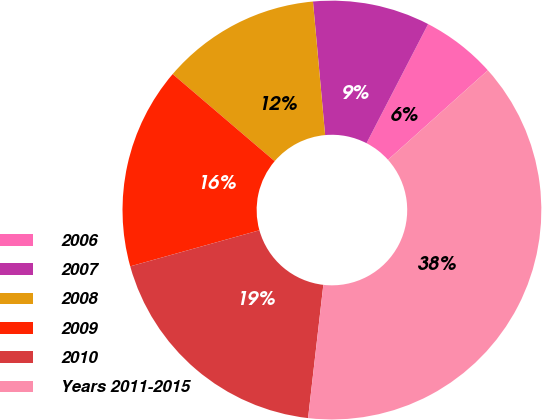Convert chart. <chart><loc_0><loc_0><loc_500><loc_500><pie_chart><fcel>2006<fcel>2007<fcel>2008<fcel>2009<fcel>2010<fcel>Years 2011-2015<nl><fcel>5.77%<fcel>9.04%<fcel>12.31%<fcel>15.58%<fcel>18.85%<fcel>38.45%<nl></chart> 